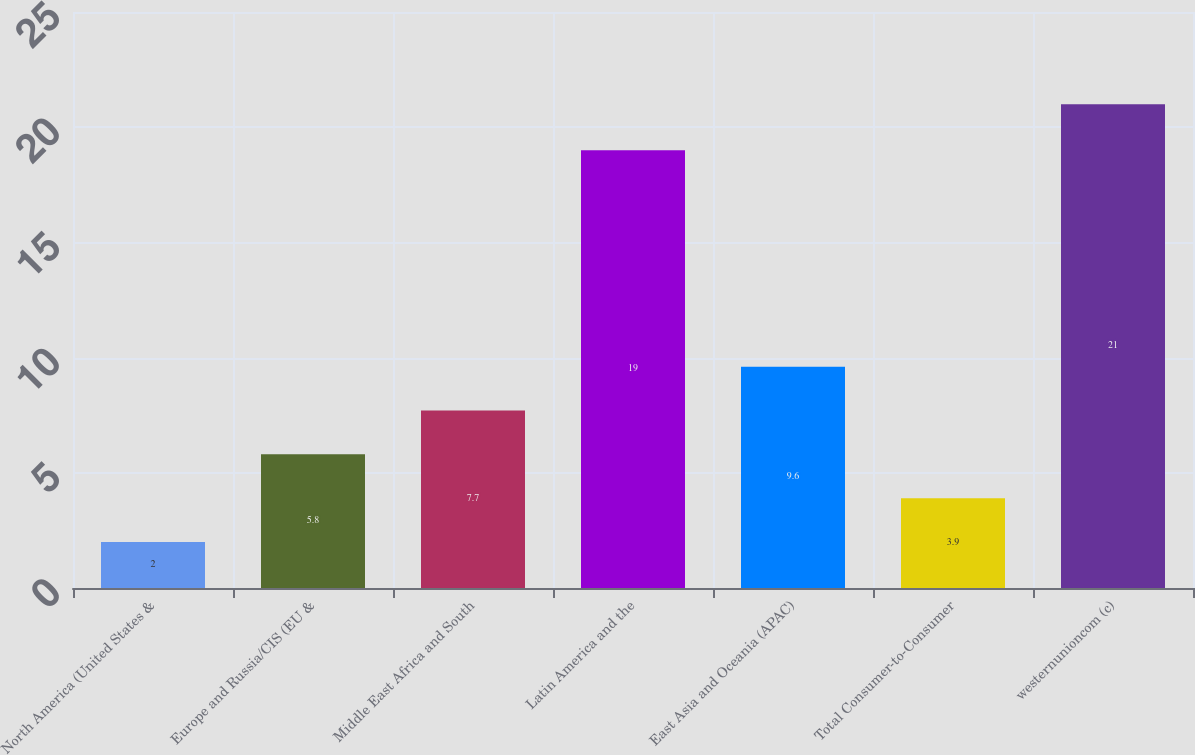Convert chart. <chart><loc_0><loc_0><loc_500><loc_500><bar_chart><fcel>North America (United States &<fcel>Europe and Russia/CIS (EU &<fcel>Middle East Africa and South<fcel>Latin America and the<fcel>East Asia and Oceania (APAC)<fcel>Total Consumer-to-Consumer<fcel>westernunioncom (c)<nl><fcel>2<fcel>5.8<fcel>7.7<fcel>19<fcel>9.6<fcel>3.9<fcel>21<nl></chart> 